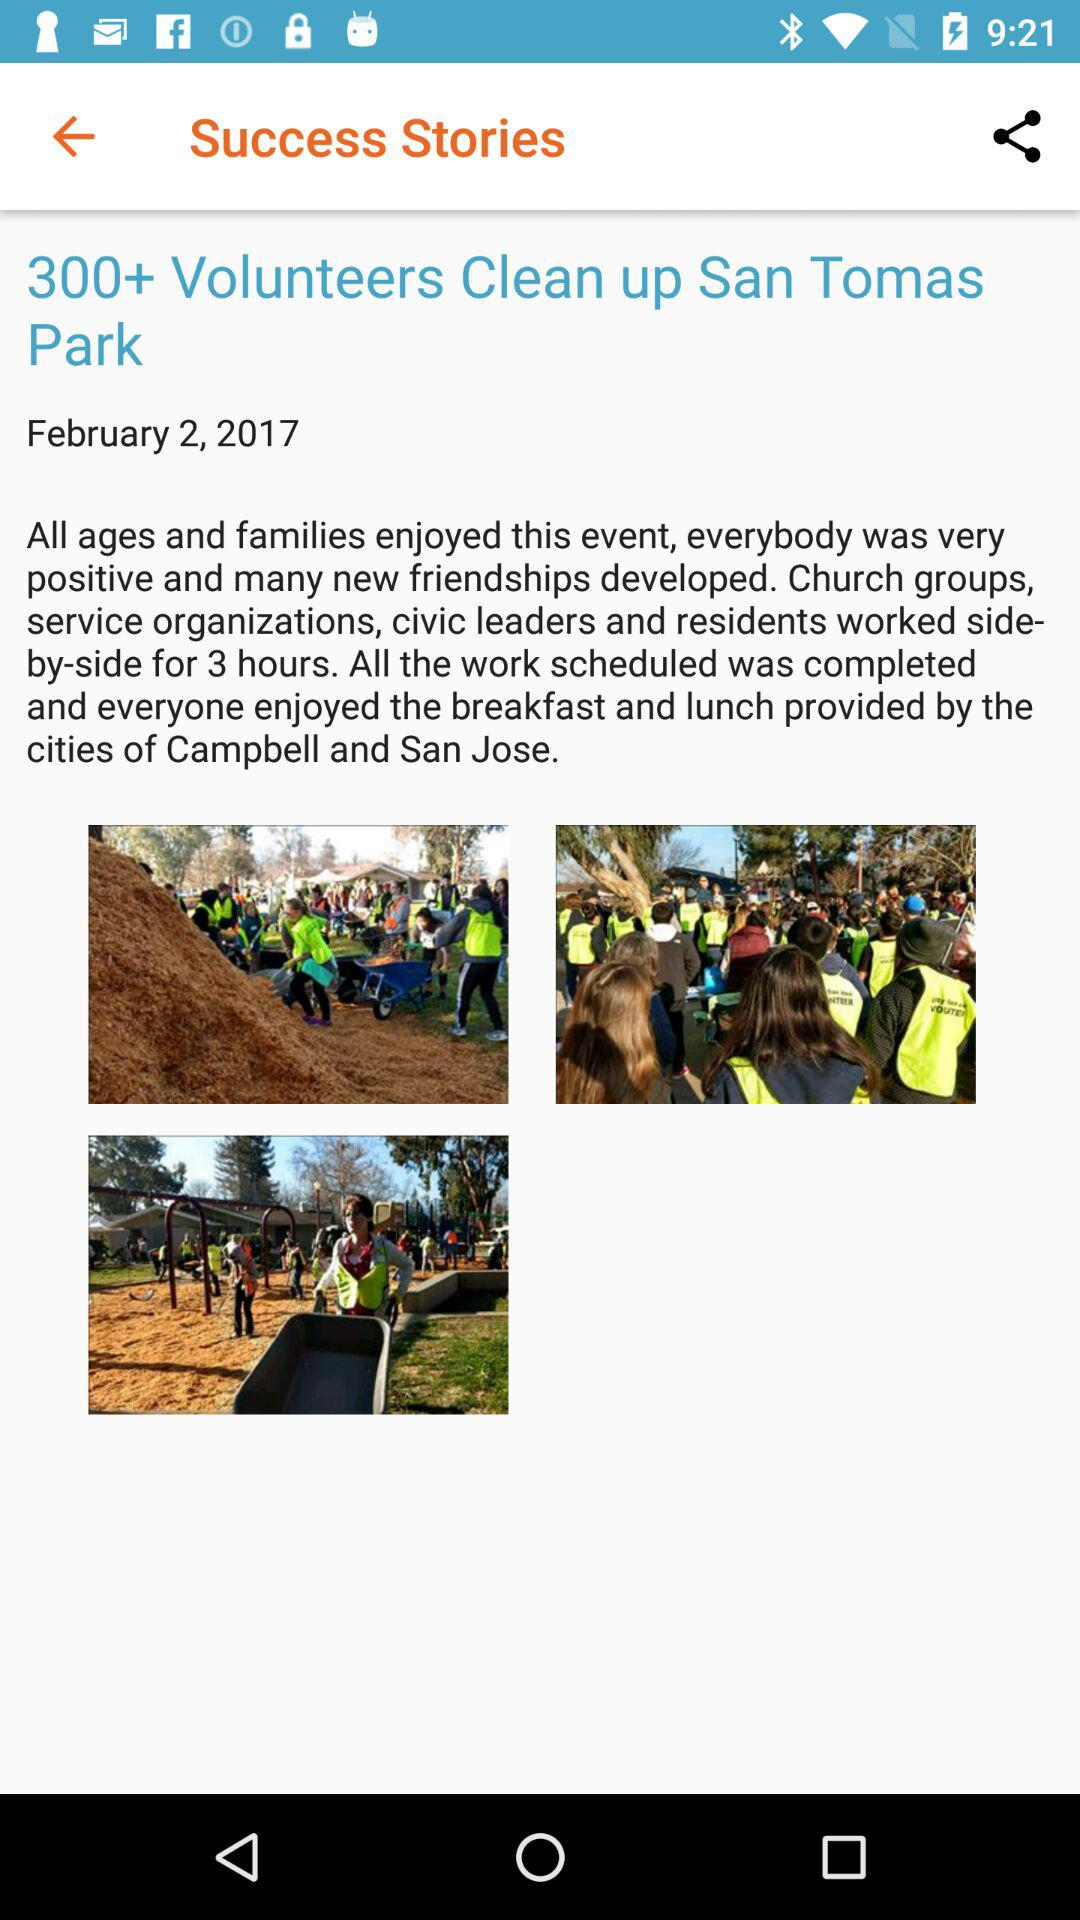How many people worked on this project?
Answer the question using a single word or phrase. 300+ 